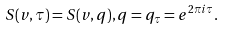<formula> <loc_0><loc_0><loc_500><loc_500>S ( v , \tau ) = S ( v , q ) , q = q _ { \tau } = e ^ { 2 \pi i \tau } .</formula> 